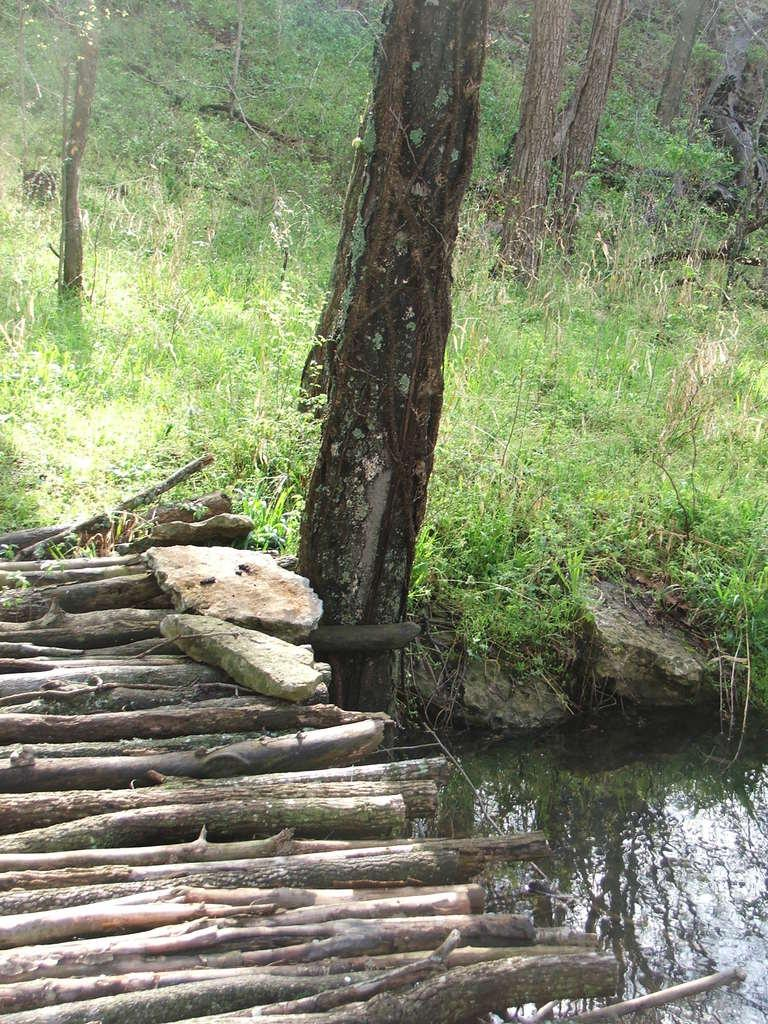What type of bridge is in the image? There is a wood bridge in the image. What other elements can be seen in the image? Stones are present in the image. What can be seen in the background of the image? There is grass, trees, and water visible in the background of the image. What type of environment might the image have been taken in? The image may have been taken in a forest. What type of scissors can be seen cutting the wood bridge in the image? There are no scissors present in the image, and the wood bridge is not being cut. What type of train can be seen passing over the wood bridge in the image? There is no train present in the image, and the wood bridge is not being used for transportation. 